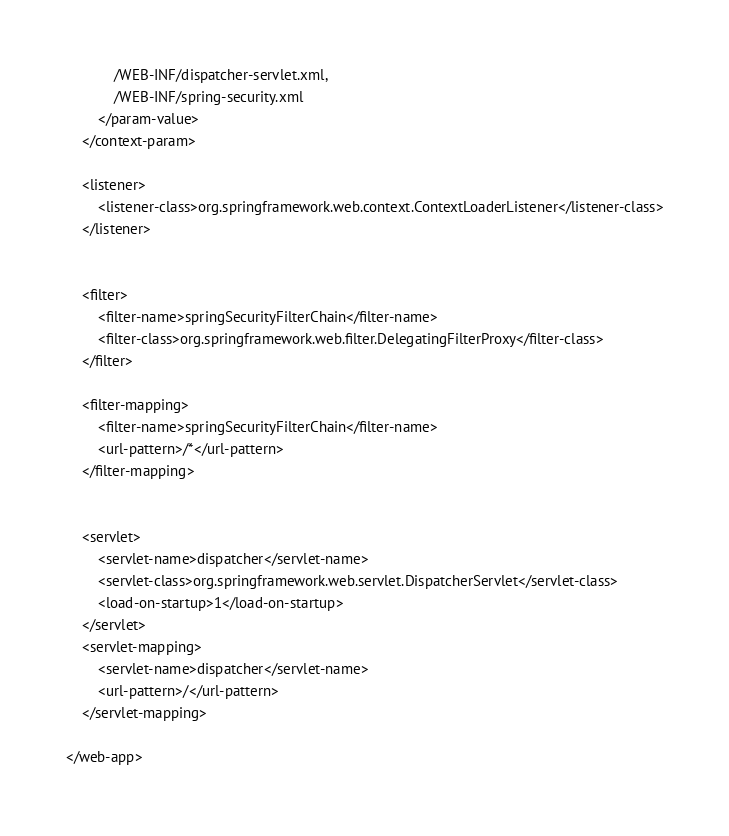<code> <loc_0><loc_0><loc_500><loc_500><_XML_>            /WEB-INF/dispatcher-servlet.xml,
            /WEB-INF/spring-security.xml
        </param-value>
    </context-param>

    <listener>
        <listener-class>org.springframework.web.context.ContextLoaderListener</listener-class>
    </listener>


    <filter>
        <filter-name>springSecurityFilterChain</filter-name>
        <filter-class>org.springframework.web.filter.DelegatingFilterProxy</filter-class>
    </filter>

    <filter-mapping>
        <filter-name>springSecurityFilterChain</filter-name>
        <url-pattern>/*</url-pattern>
    </filter-mapping>


    <servlet>
        <servlet-name>dispatcher</servlet-name>
        <servlet-class>org.springframework.web.servlet.DispatcherServlet</servlet-class>
        <load-on-startup>1</load-on-startup>
    </servlet>
    <servlet-mapping>
        <servlet-name>dispatcher</servlet-name>
        <url-pattern>/</url-pattern>
    </servlet-mapping>

</web-app>



</code> 